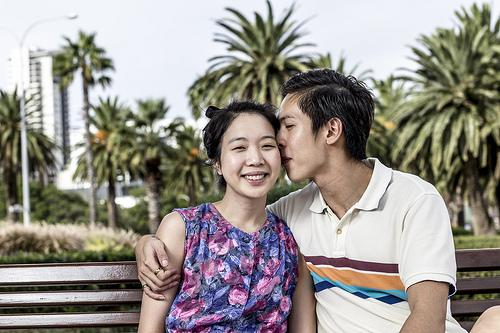Question: why is he kissing her?
Choices:
A. Deceit.
B. Passion.
C. Lust.
D. Love.
Answer with the letter. Answer: D Question: what is in the background?
Choices:
A. Graffitied wall.
B. Mountains.
C. Trees.
D. Beach.
Answer with the letter. Answer: C Question: what are they sitting on?
Choices:
A. Bench.
B. Chairs.
C. Sofas.
D. The floor.
Answer with the letter. Answer: A Question: what kind of trees?
Choices:
A. Maple.
B. Oak.
C. Willows.
D. Palm.
Answer with the letter. Answer: D 